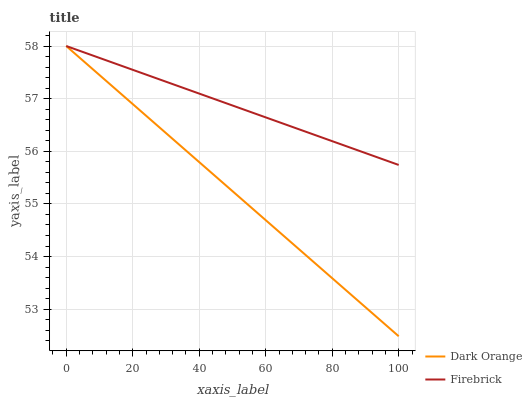Does Dark Orange have the minimum area under the curve?
Answer yes or no. Yes. Does Firebrick have the maximum area under the curve?
Answer yes or no. Yes. Does Firebrick have the minimum area under the curve?
Answer yes or no. No. Is Firebrick the smoothest?
Answer yes or no. Yes. Is Dark Orange the roughest?
Answer yes or no. Yes. Is Firebrick the roughest?
Answer yes or no. No. Does Dark Orange have the lowest value?
Answer yes or no. Yes. Does Firebrick have the lowest value?
Answer yes or no. No. Does Firebrick have the highest value?
Answer yes or no. Yes. Does Firebrick intersect Dark Orange?
Answer yes or no. Yes. Is Firebrick less than Dark Orange?
Answer yes or no. No. Is Firebrick greater than Dark Orange?
Answer yes or no. No. 